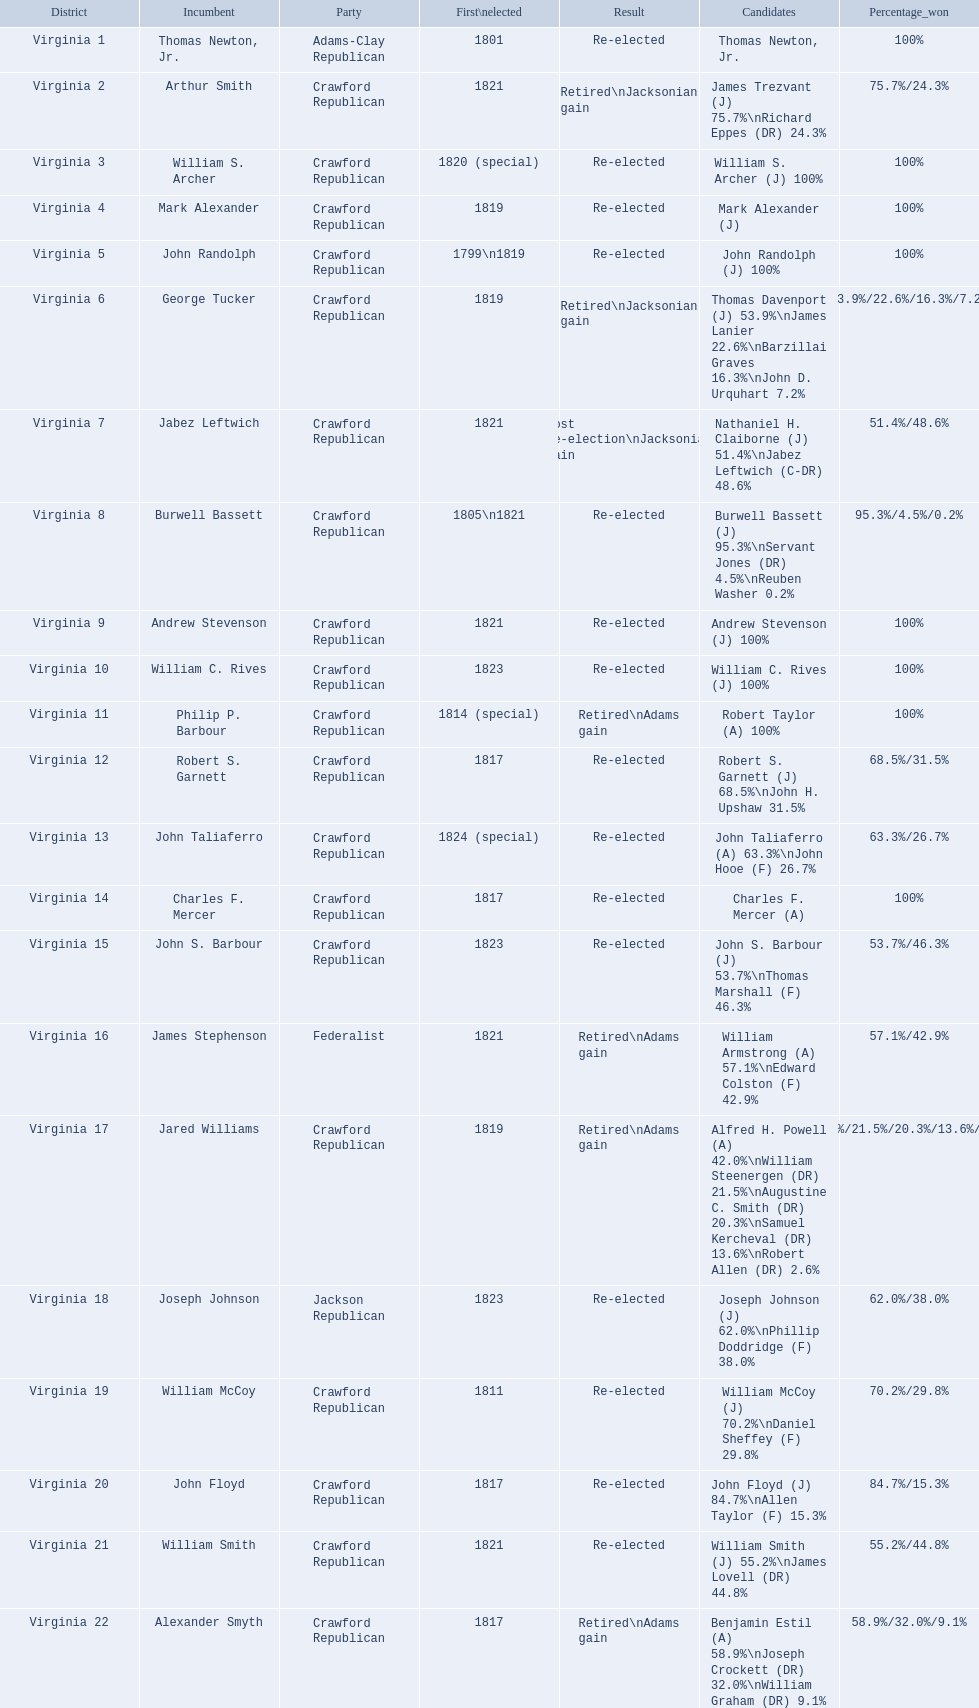What party is a crawford republican? Crawford Republican, Crawford Republican, Crawford Republican, Crawford Republican, Crawford Republican, Crawford Republican, Crawford Republican, Crawford Republican, Crawford Republican, Crawford Republican, Crawford Republican, Crawford Republican, Crawford Republican, Crawford Republican, Crawford Republican, Crawford Republican, Crawford Republican, Crawford Republican, Crawford Republican. What candidates have over 76%? James Trezvant (J) 75.7%\nRichard Eppes (DR) 24.3%, William S. Archer (J) 100%, John Randolph (J) 100%, Burwell Bassett (J) 95.3%\nServant Jones (DR) 4.5%\nReuben Washer 0.2%, Andrew Stevenson (J) 100%, William C. Rives (J) 100%, Robert Taylor (A) 100%, John Floyd (J) 84.7%\nAllen Taylor (F) 15.3%. Which result was retired jacksonian gain? Retired\nJacksonian gain. Who was the incumbent? Arthur Smith. 